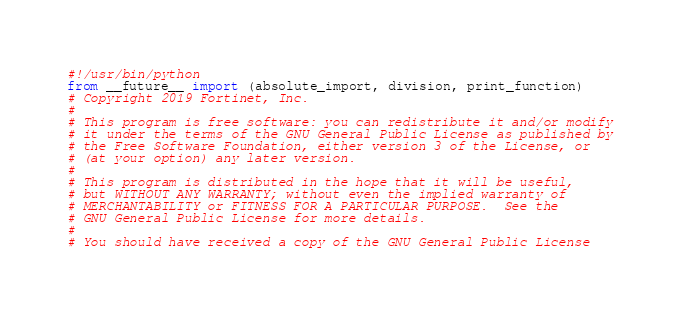Convert code to text. <code><loc_0><loc_0><loc_500><loc_500><_Python_>#!/usr/bin/python
from __future__ import (absolute_import, division, print_function)
# Copyright 2019 Fortinet, Inc.
#
# This program is free software: you can redistribute it and/or modify
# it under the terms of the GNU General Public License as published by
# the Free Software Foundation, either version 3 of the License, or
# (at your option) any later version.
#
# This program is distributed in the hope that it will be useful,
# but WITHOUT ANY WARRANTY; without even the implied warranty of
# MERCHANTABILITY or FITNESS FOR A PARTICULAR PURPOSE.  See the
# GNU General Public License for more details.
#
# You should have received a copy of the GNU General Public License</code> 